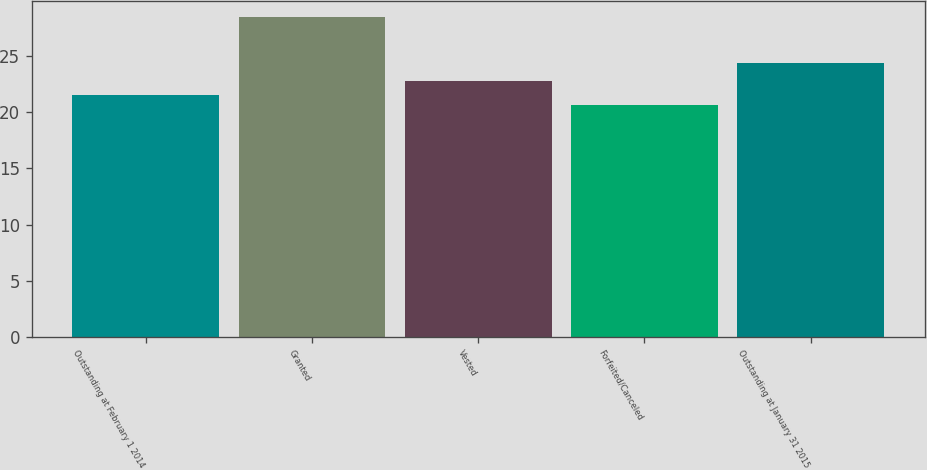Convert chart to OTSL. <chart><loc_0><loc_0><loc_500><loc_500><bar_chart><fcel>Outstanding at February 1 2014<fcel>Granted<fcel>Vested<fcel>Forfeited/Canceled<fcel>Outstanding at January 31 2015<nl><fcel>21.49<fcel>28.49<fcel>22.77<fcel>20.68<fcel>24.4<nl></chart> 